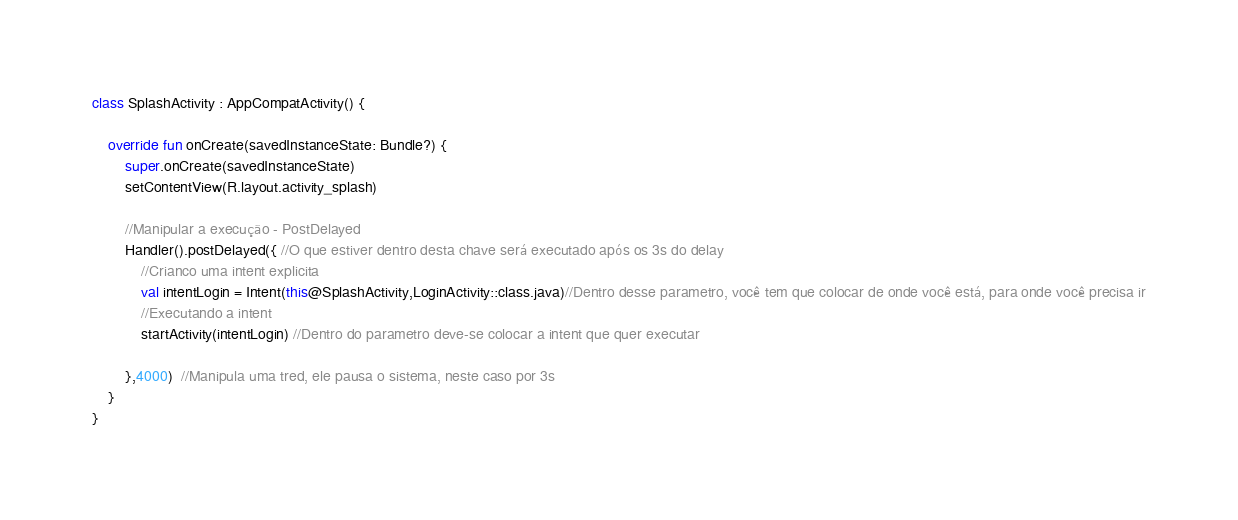<code> <loc_0><loc_0><loc_500><loc_500><_Kotlin_>
class SplashActivity : AppCompatActivity() {

    override fun onCreate(savedInstanceState: Bundle?) {
        super.onCreate(savedInstanceState)
        setContentView(R.layout.activity_splash)

        //Manipular a execução - PostDelayed
        Handler().postDelayed({ //O que estiver dentro desta chave será executado após os 3s do delay
            //Crianco uma intent explicita
            val intentLogin = Intent(this@SplashActivity,LoginActivity::class.java)//Dentro desse parametro, você tem que colocar de onde você está, para onde você precisa ir
            //Executando a intent
            startActivity(intentLogin) //Dentro do parametro deve-se colocar a intent que quer executar

        },4000)  //Manipula uma tred, ele pausa o sistema, neste caso por 3s
    }
}
</code> 